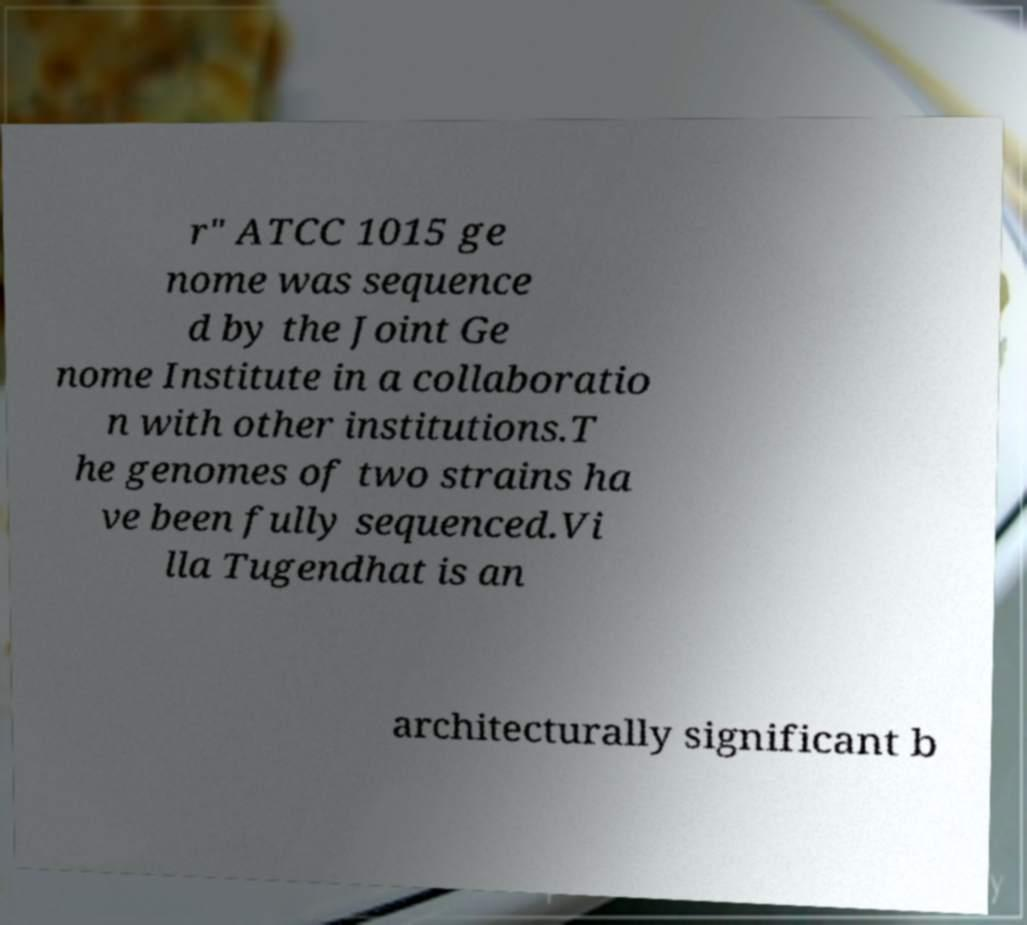I need the written content from this picture converted into text. Can you do that? r" ATCC 1015 ge nome was sequence d by the Joint Ge nome Institute in a collaboratio n with other institutions.T he genomes of two strains ha ve been fully sequenced.Vi lla Tugendhat is an architecturally significant b 